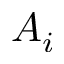<formula> <loc_0><loc_0><loc_500><loc_500>A _ { i }</formula> 